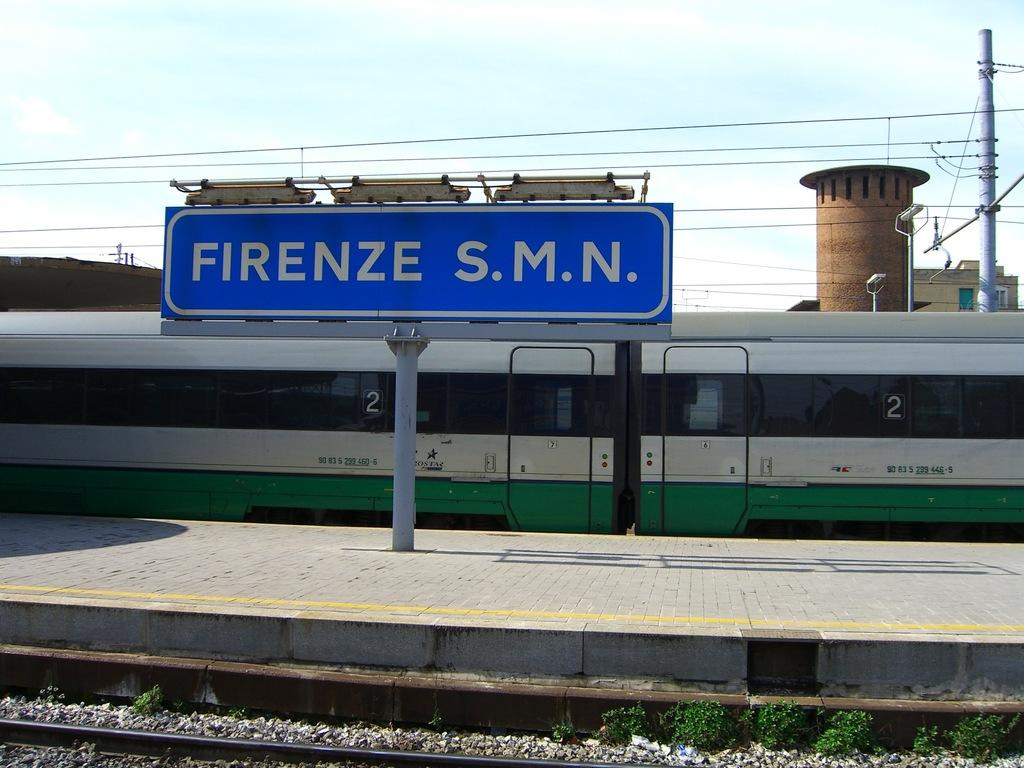<image>
Describe the image concisely. A blue and white sign next to a train platform reads firenze on it. 